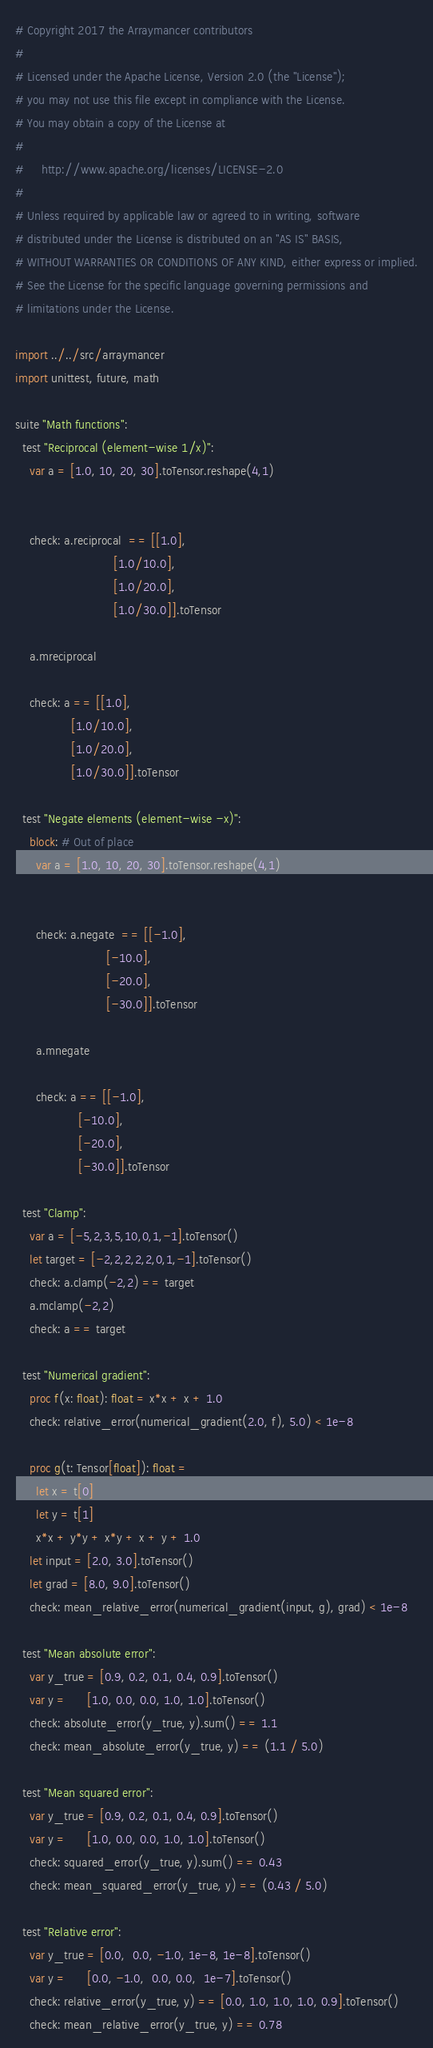Convert code to text. <code><loc_0><loc_0><loc_500><loc_500><_Nim_># Copyright 2017 the Arraymancer contributors
#
# Licensed under the Apache License, Version 2.0 (the "License");
# you may not use this file except in compliance with the License.
# You may obtain a copy of the License at
#
#     http://www.apache.org/licenses/LICENSE-2.0
#
# Unless required by applicable law or agreed to in writing, software
# distributed under the License is distributed on an "AS IS" BASIS,
# WITHOUT WARRANTIES OR CONDITIONS OF ANY KIND, either express or implied.
# See the License for the specific language governing permissions and
# limitations under the License.

import ../../src/arraymancer
import unittest, future, math

suite "Math functions":
  test "Reciprocal (element-wise 1/x)":
    var a = [1.0, 10, 20, 30].toTensor.reshape(4,1)


    check: a.reciprocal  == [[1.0],
                            [1.0/10.0],
                            [1.0/20.0],
                            [1.0/30.0]].toTensor

    a.mreciprocal

    check: a == [[1.0],
                [1.0/10.0],
                [1.0/20.0],
                [1.0/30.0]].toTensor

  test "Negate elements (element-wise -x)":
    block: # Out of place
      var a = [1.0, 10, 20, 30].toTensor.reshape(4,1)


      check: a.negate  == [[-1.0],
                          [-10.0],
                          [-20.0],
                          [-30.0]].toTensor

      a.mnegate

      check: a == [[-1.0],
                  [-10.0],
                  [-20.0],
                  [-30.0]].toTensor

  test "Clamp":
    var a = [-5,2,3,5,10,0,1,-1].toTensor()
    let target = [-2,2,2,2,2,0,1,-1].toTensor()
    check: a.clamp(-2,2) == target
    a.mclamp(-2,2)
    check: a == target

  test "Numerical gradient":
    proc f(x: float): float = x*x + x + 1.0
    check: relative_error(numerical_gradient(2.0, f), 5.0) < 1e-8

    proc g(t: Tensor[float]): float =
      let x = t[0]
      let y = t[1]
      x*x + y*y + x*y + x + y + 1.0
    let input = [2.0, 3.0].toTensor()
    let grad = [8.0, 9.0].toTensor()
    check: mean_relative_error(numerical_gradient(input, g), grad) < 1e-8

  test "Mean absolute error":
    var y_true = [0.9, 0.2, 0.1, 0.4, 0.9].toTensor()
    var y =      [1.0, 0.0, 0.0, 1.0, 1.0].toTensor()
    check: absolute_error(y_true, y).sum() == 1.1
    check: mean_absolute_error(y_true, y) == (1.1 / 5.0)

  test "Mean squared error":
    var y_true = [0.9, 0.2, 0.1, 0.4, 0.9].toTensor()
    var y =      [1.0, 0.0, 0.0, 1.0, 1.0].toTensor()
    check: squared_error(y_true, y).sum() == 0.43
    check: mean_squared_error(y_true, y) == (0.43 / 5.0)

  test "Relative error":
    var y_true = [0.0,  0.0, -1.0, 1e-8, 1e-8].toTensor()
    var y =      [0.0, -1.0,  0.0, 0.0,  1e-7].toTensor()
    check: relative_error(y_true, y) == [0.0, 1.0, 1.0, 1.0, 0.9].toTensor()
    check: mean_relative_error(y_true, y) == 0.78</code> 